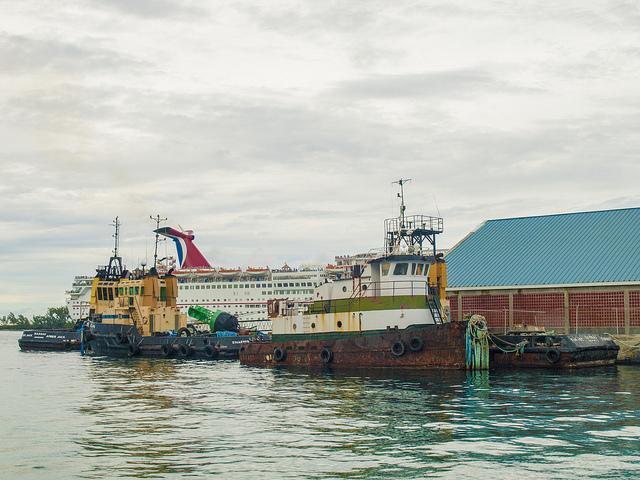How many boats are docked at this pier?
Give a very brief answer. 3. How many boats are there?
Give a very brief answer. 3. How many zebras can you count?
Give a very brief answer. 0. 